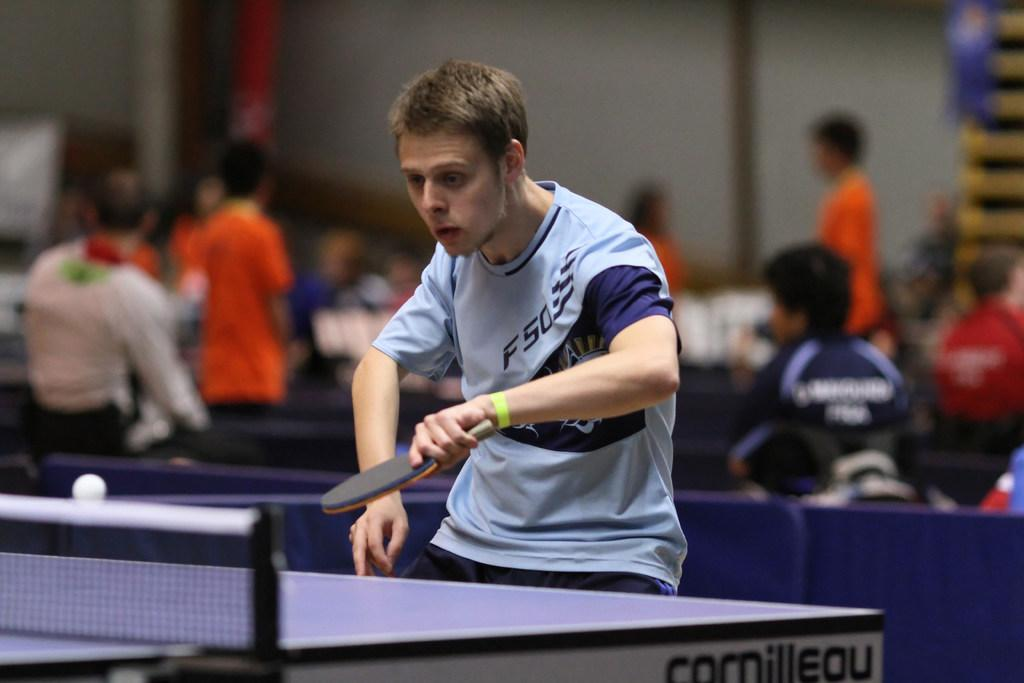What is the person in the image doing? The person in the image is playing a game. What object is the person holding while playing the game? The person is holding a bat. What color is the shirt the person is wearing? The person is wearing a blue shirt. Can you describe the people in the background of the image? There are other people standing at the back, and some people are sitting at the back. What type of digestion can be observed in the image? There is no digestion present in the image; it features a person playing a game with a bat. What kind of animal is sitting at the back in the image? There are no animals present in the image; it only shows people playing a game and standing or sitting in the background. 